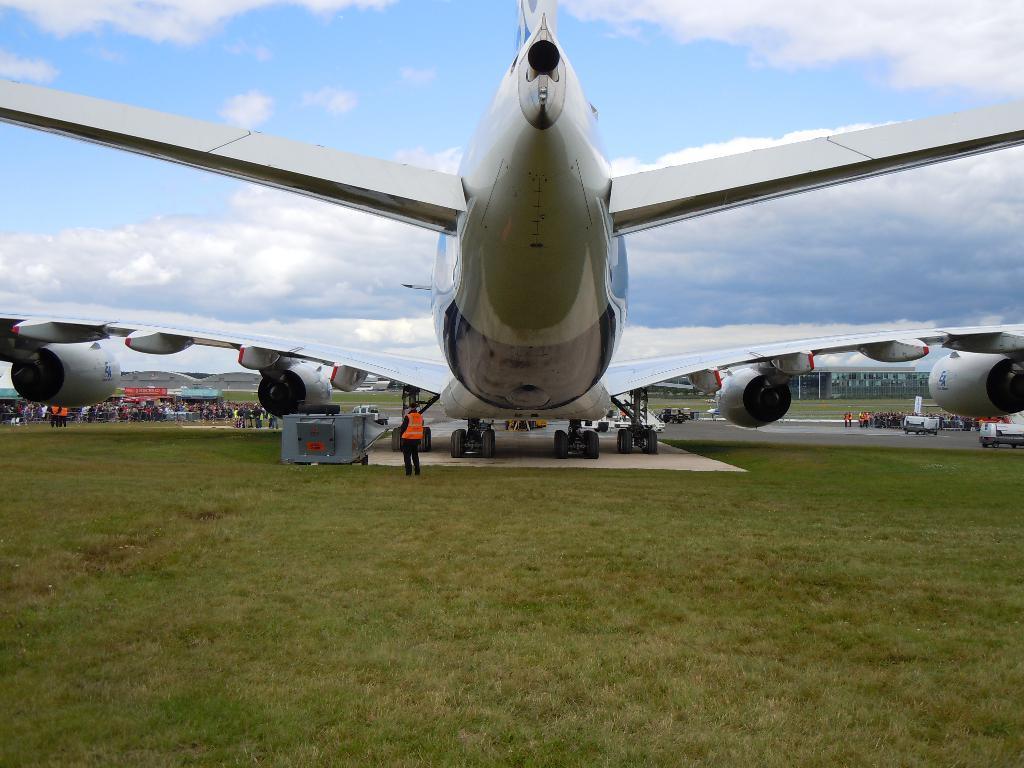Can you describe this image briefly? In this image we can see an aircraft. Behind the aircraft we can see the vehicles and persons. At the bottom we can see the grass. At the top we can see the sky. 